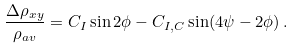Convert formula to latex. <formula><loc_0><loc_0><loc_500><loc_500>\frac { \Delta \rho _ { x y } } { \rho _ { a v } } = C _ { I } \sin 2 \phi - C _ { I , C } \sin ( 4 \psi - 2 \phi ) \, .</formula> 